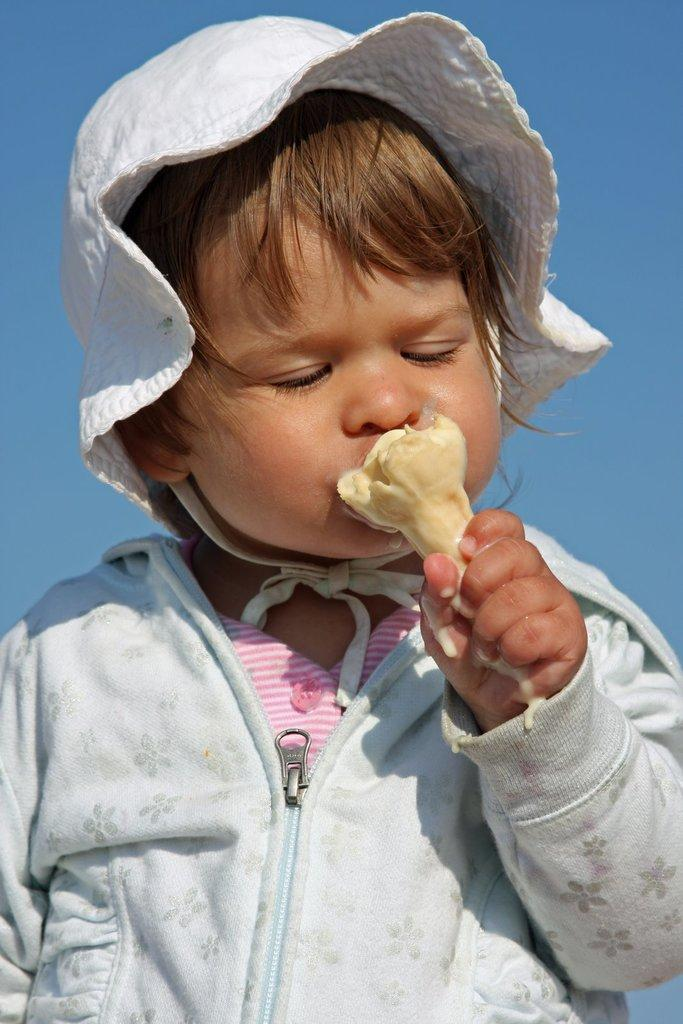What is the main subject of the image? There is a child in the image. What is the child doing in the image? The child is holding food. What can be seen in the background of the image? There is sky visible in the background of the image. What type of sock is the child wearing in the image? There is no sock visible in the image, as the child is not wearing any footwear. 